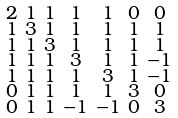Convert formula to latex. <formula><loc_0><loc_0><loc_500><loc_500>\begin{smallmatrix} 2 & 1 & 1 & 1 & 1 & 0 & 0 \\ 1 & 3 & 1 & 1 & 1 & 1 & 1 \\ 1 & 1 & 3 & 1 & 1 & 1 & 1 \\ 1 & 1 & 1 & 3 & 1 & 1 & - 1 \\ 1 & 1 & 1 & 1 & 3 & 1 & - 1 \\ 0 & 1 & 1 & 1 & 1 & 3 & 0 \\ 0 & 1 & 1 & - 1 & - 1 & 0 & 3 \end{smallmatrix}</formula> 